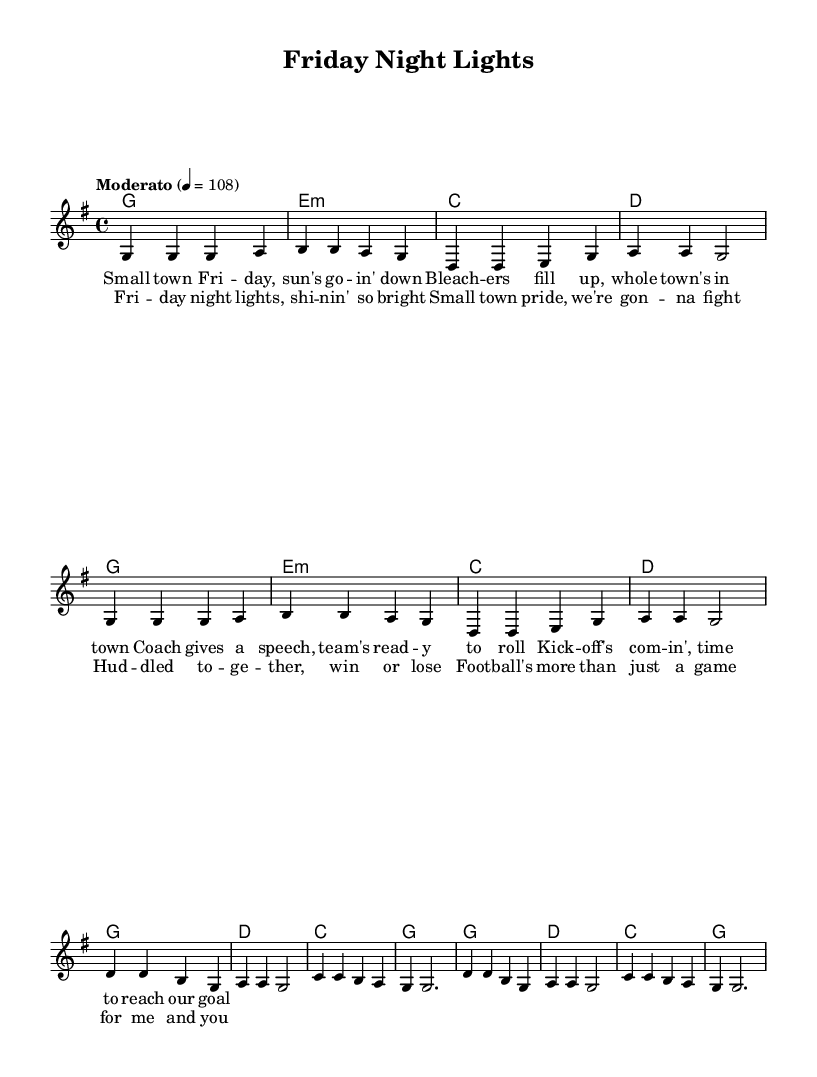What is the key signature of this music? The key signature is G major, which has one sharp (F#) indicated at the beginning of the staff.
Answer: G major What is the time signature of this music? The time signature is indicated as 4/4, which means there are four beats in a measure and a quarter note receives one beat.
Answer: 4/4 What is the tempo marking of this piece? The tempo marking states "Moderato," which defines a moderate pace, and is further quantified as a quarter note equaling 108 beats per minute.
Answer: Moderato How many measures are in the verse? The verse is structured into 8 measures, as identified by the grouping of notes, each separated by bar lines.
Answer: 8 measures How is the chorus different from the verse in terms of lyric length? The chorus has a more condensed lyric structure that repeats several phrases, making it shorter in total verse syllables when compared to the verse.
Answer: Shorter What themes are celebrated in the lyrics? The lyrics reflect a strong sense of community, pride, and the significance of football in small-town culture, emphasizing togetherness and collective spirit during game time.
Answer: Community pride Which musical element is emphasized by the repetition in the chorus? The repetition in the chorus emphasizes the core message of unity and the passion for football, making it the main theme of the song, designed to resonate emotionally with the audience.
Answer: Unity 